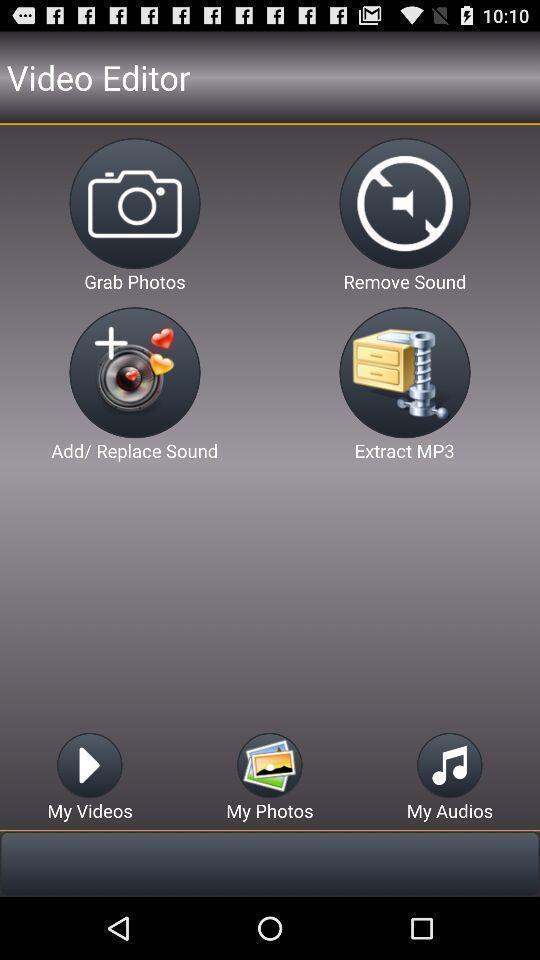Give me a summary of this screen capture. Page showing different options for editing. 